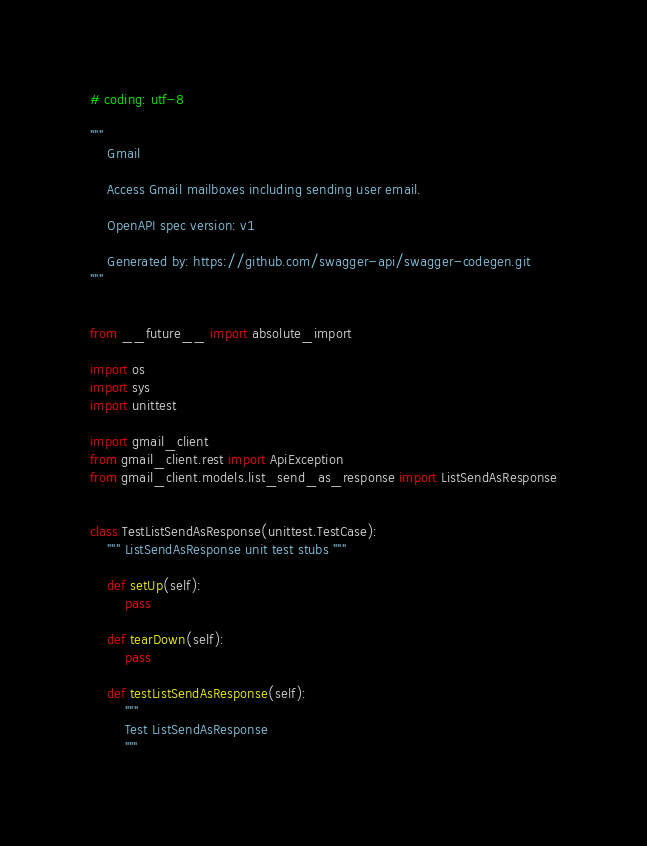Convert code to text. <code><loc_0><loc_0><loc_500><loc_500><_Python_># coding: utf-8

"""
    Gmail

    Access Gmail mailboxes including sending user email.

    OpenAPI spec version: v1
    
    Generated by: https://github.com/swagger-api/swagger-codegen.git
"""


from __future__ import absolute_import

import os
import sys
import unittest

import gmail_client
from gmail_client.rest import ApiException
from gmail_client.models.list_send_as_response import ListSendAsResponse


class TestListSendAsResponse(unittest.TestCase):
    """ ListSendAsResponse unit test stubs """

    def setUp(self):
        pass

    def tearDown(self):
        pass

    def testListSendAsResponse(self):
        """
        Test ListSendAsResponse
        """</code> 